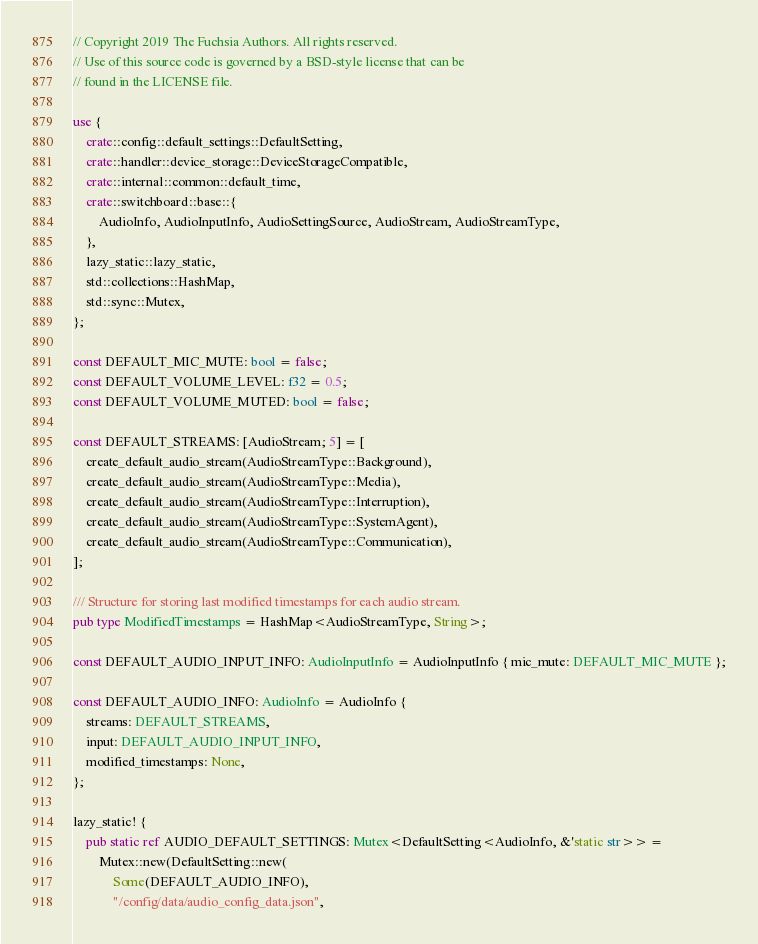Convert code to text. <code><loc_0><loc_0><loc_500><loc_500><_Rust_>// Copyright 2019 The Fuchsia Authors. All rights reserved.
// Use of this source code is governed by a BSD-style license that can be
// found in the LICENSE file.

use {
    crate::config::default_settings::DefaultSetting,
    crate::handler::device_storage::DeviceStorageCompatible,
    crate::internal::common::default_time,
    crate::switchboard::base::{
        AudioInfo, AudioInputInfo, AudioSettingSource, AudioStream, AudioStreamType,
    },
    lazy_static::lazy_static,
    std::collections::HashMap,
    std::sync::Mutex,
};

const DEFAULT_MIC_MUTE: bool = false;
const DEFAULT_VOLUME_LEVEL: f32 = 0.5;
const DEFAULT_VOLUME_MUTED: bool = false;

const DEFAULT_STREAMS: [AudioStream; 5] = [
    create_default_audio_stream(AudioStreamType::Background),
    create_default_audio_stream(AudioStreamType::Media),
    create_default_audio_stream(AudioStreamType::Interruption),
    create_default_audio_stream(AudioStreamType::SystemAgent),
    create_default_audio_stream(AudioStreamType::Communication),
];

/// Structure for storing last modified timestamps for each audio stream.
pub type ModifiedTimestamps = HashMap<AudioStreamType, String>;

const DEFAULT_AUDIO_INPUT_INFO: AudioInputInfo = AudioInputInfo { mic_mute: DEFAULT_MIC_MUTE };

const DEFAULT_AUDIO_INFO: AudioInfo = AudioInfo {
    streams: DEFAULT_STREAMS,
    input: DEFAULT_AUDIO_INPUT_INFO,
    modified_timestamps: None,
};

lazy_static! {
    pub static ref AUDIO_DEFAULT_SETTINGS: Mutex<DefaultSetting<AudioInfo, &'static str>> =
        Mutex::new(DefaultSetting::new(
            Some(DEFAULT_AUDIO_INFO),
            "/config/data/audio_config_data.json",</code> 